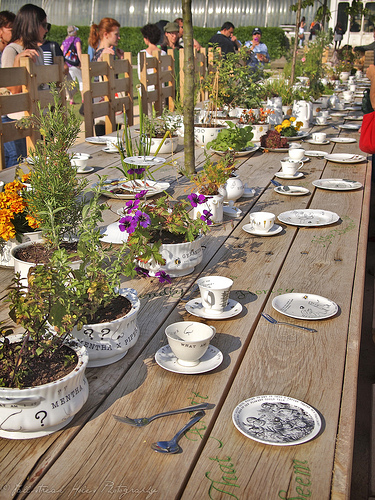<image>
Is there a plate on the table? Yes. Looking at the image, I can see the plate is positioned on top of the table, with the table providing support. Is the fork on the plate? No. The fork is not positioned on the plate. They may be near each other, but the fork is not supported by or resting on top of the plate. Is there a plate above the table? No. The plate is not positioned above the table. The vertical arrangement shows a different relationship. 